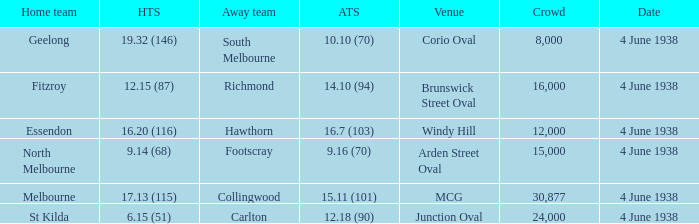How many attended the game at Arden Street Oval? 15000.0. 